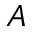Convert formula to latex. <formula><loc_0><loc_0><loc_500><loc_500>A</formula> 